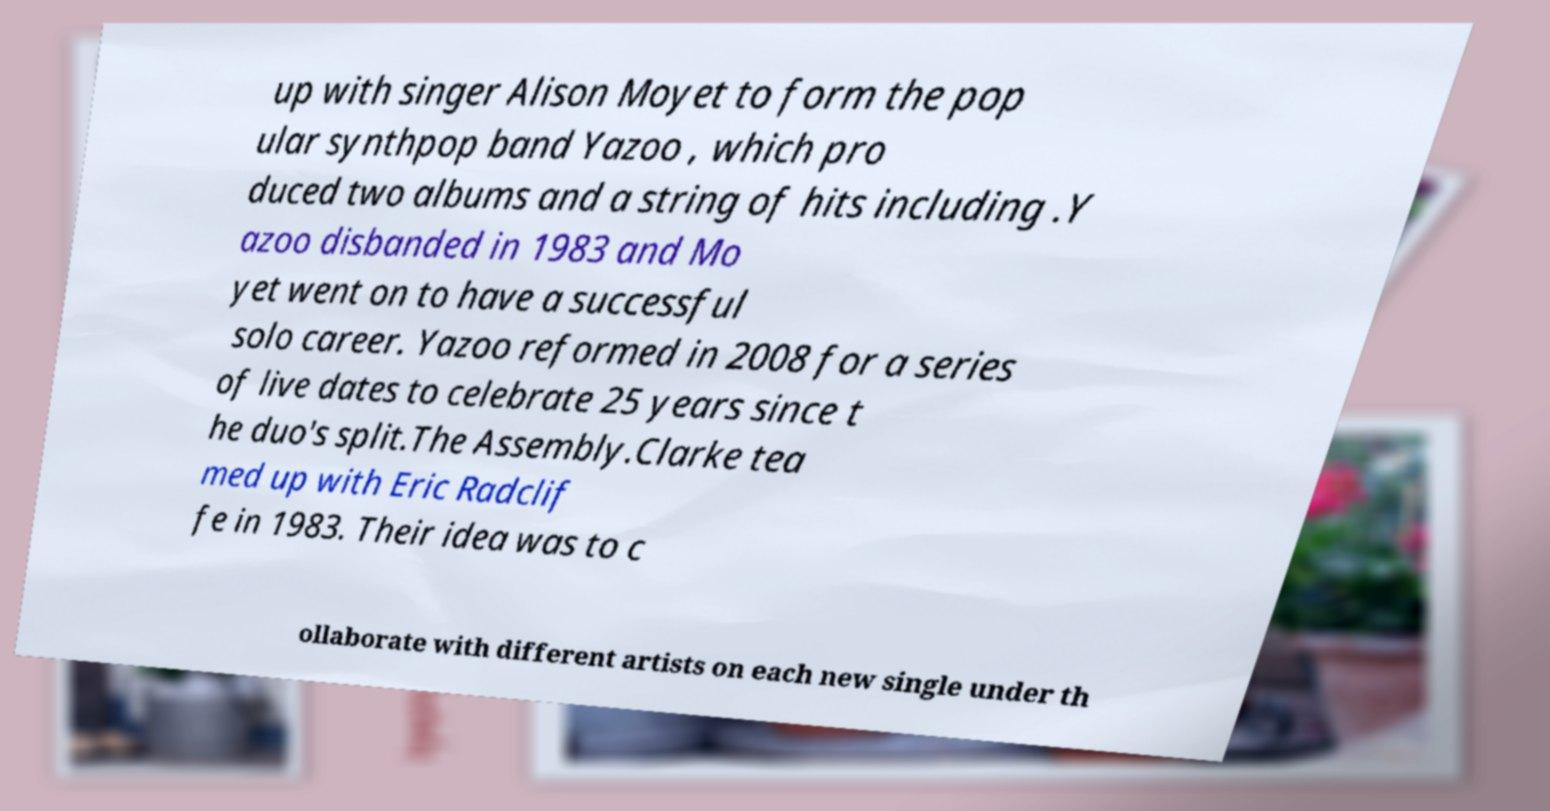Can you read and provide the text displayed in the image?This photo seems to have some interesting text. Can you extract and type it out for me? up with singer Alison Moyet to form the pop ular synthpop band Yazoo , which pro duced two albums and a string of hits including .Y azoo disbanded in 1983 and Mo yet went on to have a successful solo career. Yazoo reformed in 2008 for a series of live dates to celebrate 25 years since t he duo's split.The Assembly.Clarke tea med up with Eric Radclif fe in 1983. Their idea was to c ollaborate with different artists on each new single under th 